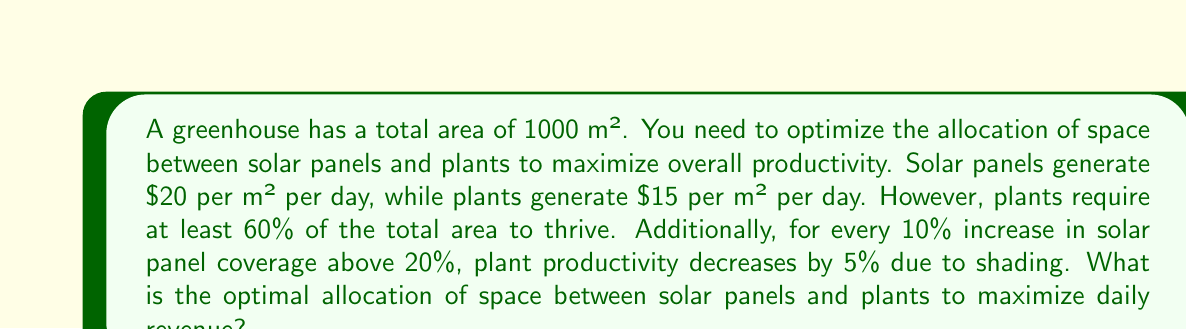Help me with this question. Let's approach this step-by-step:

1) Let $x$ be the percentage of area allocated to solar panels. Then, $(100-x)$ is the percentage allocated to plants.

2) Given the constraints:
   - Plants require at least 60% of the area: $x \leq 40$
   - We start considering productivity decrease when $x > 20$

3) Let's define the revenue function:

   $R(x) = 20 \cdot 10x + 15 \cdot 10(100-x) \cdot f(x)$

   Where $f(x)$ is the productivity factor for plants:
   
   $f(x) = \begin{cases} 
   1 & \text{if } x \leq 20 \\
   1 - 0.05 \cdot \lfloor\frac{x-20}{10}\rfloor & \text{if } 20 < x \leq 40
   \end{cases}$

4) Let's calculate revenues for different allocations:

   For $x = 20$: $R(20) = 20 \cdot 200 + 15 \cdot 800 = 16000$
   
   For $x = 30$: $R(30) = 20 \cdot 300 + 15 \cdot 700 \cdot 0.95 = 16025$
   
   For $x = 40$: $R(40) = 20 \cdot 400 + 15 \cdot 600 \cdot 0.90 = 16100$

5) We can see that revenue increases as we approach 40% solar panel coverage, despite the decrease in plant productivity.

Therefore, the optimal allocation is 40% for solar panels and 60% for plants, which maximizes daily revenue.
Answer: The optimal allocation is 40% (400 m²) for solar panels and 60% (600 m²) for plants, generating a daily revenue of $16,100. 